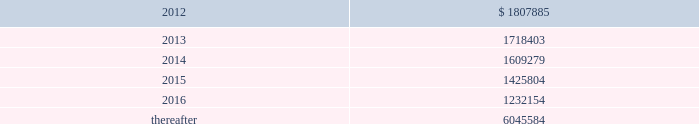Vornado realty trust notes to consolidated financial statements ( continued ) 17 .
Leases as lessor : we lease space to tenants under operating leases .
Most of the leases provide for the payment of fixed base rentals payable monthly in advance .
Office building leases generally require the tenants to reimburse us for operating costs and real estate taxes above their base year costs .
Shopping center leases provide for pass-through to tenants the tenant 2019s share of real estate taxes , insurance and maintenance .
Shopping center leases also provide for the payment by the lessee of additional rent based on a percentage of the tenants 2019 sales .
As of december 31 , 2011 , future base rental revenue under non-cancelable operating leases , excluding rents for leases with an original term of less than one year and rents resulting from the exercise of renewal options , is as follows : ( amounts in thousands ) year ending december 31: .
These amounts do not include percentage rentals based on tenants 2019 sales .
These percentage rents approximated $ 8482000 , $ 7912000 and $ 8394000 , for the years ended december 31 , 2011 , 2010 and 2009 , respectively .
None of our tenants accounted for more than 10% ( 10 % ) of total revenues in any of the years ended december 31 , 2011 , 2010 and 2009 .
Former bradlees locations pursuant to a master agreement and guaranty , dated may 1 , 1992 , we are due $ 5000000 per annum of additional rent from stop & shop which was allocated to certain bradlees former locations .
On december 31 , 2002 , prior to the expiration of the leases to which the additional rent was allocated , we reallocated this rent to other former bradlees leases also guaranteed by stop & shop .
Stop & shop is contesting our right to reallocate and claims that we are no longer entitled to the additional rent .
On november 7 , 2011 , the court determined that we have a continuing right to allocate the annual rent to unexpired leases covered by the master agreement and guaranty and directed entry of a judgment in our favor ordering stop & shop to pay us the unpaid annual rent ( see note 20 2013 commitments and contingencies 2013 litigation ) .
As of december 31 , 2011 , we have a $ 41983000 receivable from stop and shop. .
Percentage rentals based on tenants 2019 sales totaled how much for the years ended december 31 , 2011 and 2010 , in thousands? 
Computations: (8482000 + 7912000)
Answer: 16394000.0. 